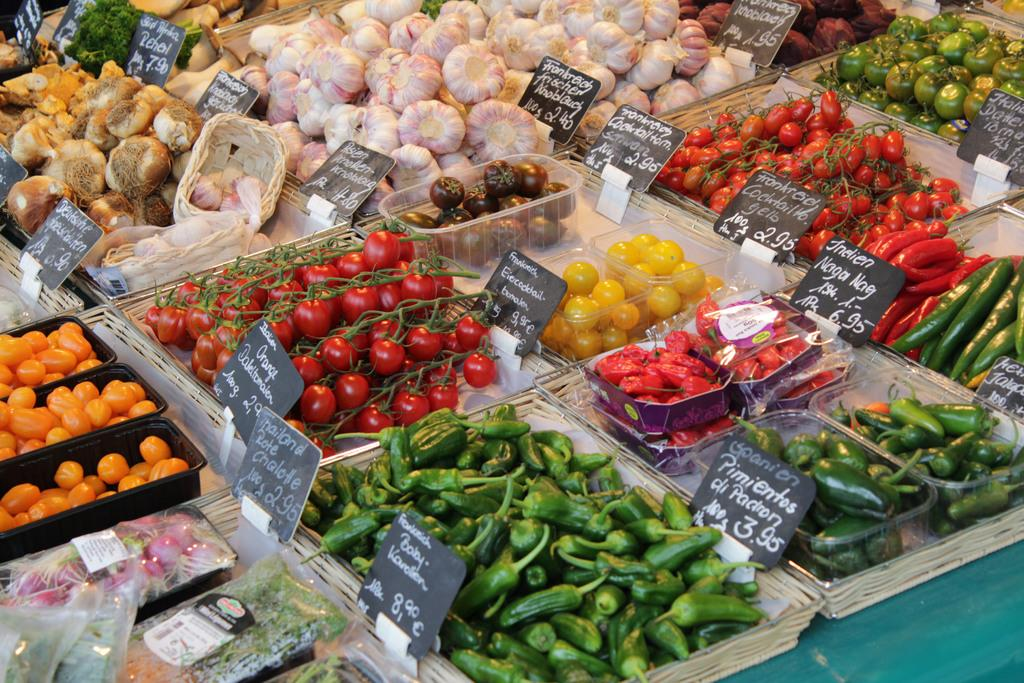What objects are present in the image that hold food items? There are trays in the image. What type of food items can be seen on the trays? The trays contain different kinds of vegetables. How can customers determine the price of the vegetables? There are price boards associated with the vegetables. What is the opinion of the vegetables on the trays in the image? The image does not convey an opinion about the vegetables; it simply shows trays containing different kinds of vegetables. 